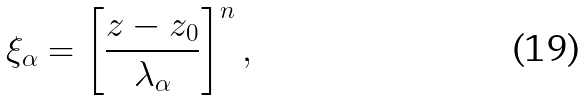<formula> <loc_0><loc_0><loc_500><loc_500>\xi _ { \alpha } = \left [ \frac { z - z _ { 0 } } { \lambda _ { \alpha } } \right ] ^ { n } ,</formula> 